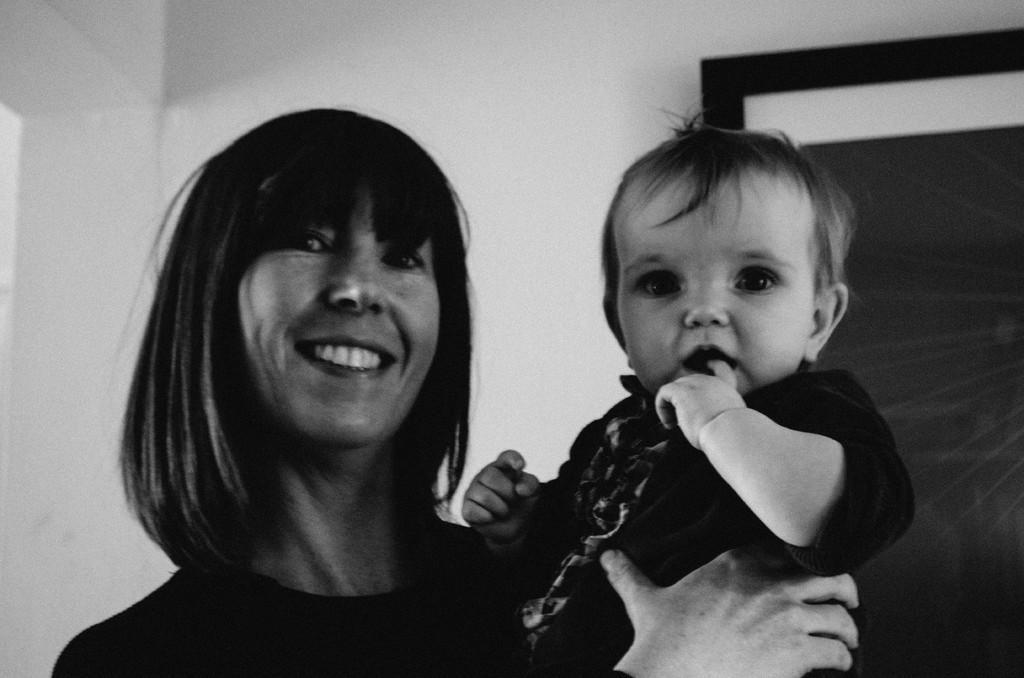Describe this image in one or two sentences. In this image we can see a lady holding a baby. In the back there is a wall with an object. And this is a black and white image. 